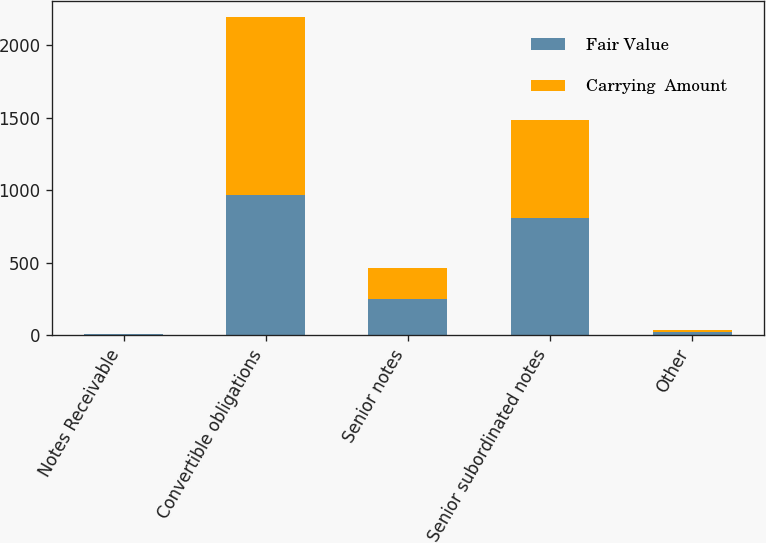<chart> <loc_0><loc_0><loc_500><loc_500><stacked_bar_chart><ecel><fcel>Notes Receivable<fcel>Convertible obligations<fcel>Senior notes<fcel>Senior subordinated notes<fcel>Other<nl><fcel>Fair Value<fcel>2.7<fcel>969.1<fcel>250<fcel>806.3<fcel>18.1<nl><fcel>Carrying  Amount<fcel>2.7<fcel>1227.7<fcel>209.3<fcel>675.9<fcel>18.1<nl></chart> 